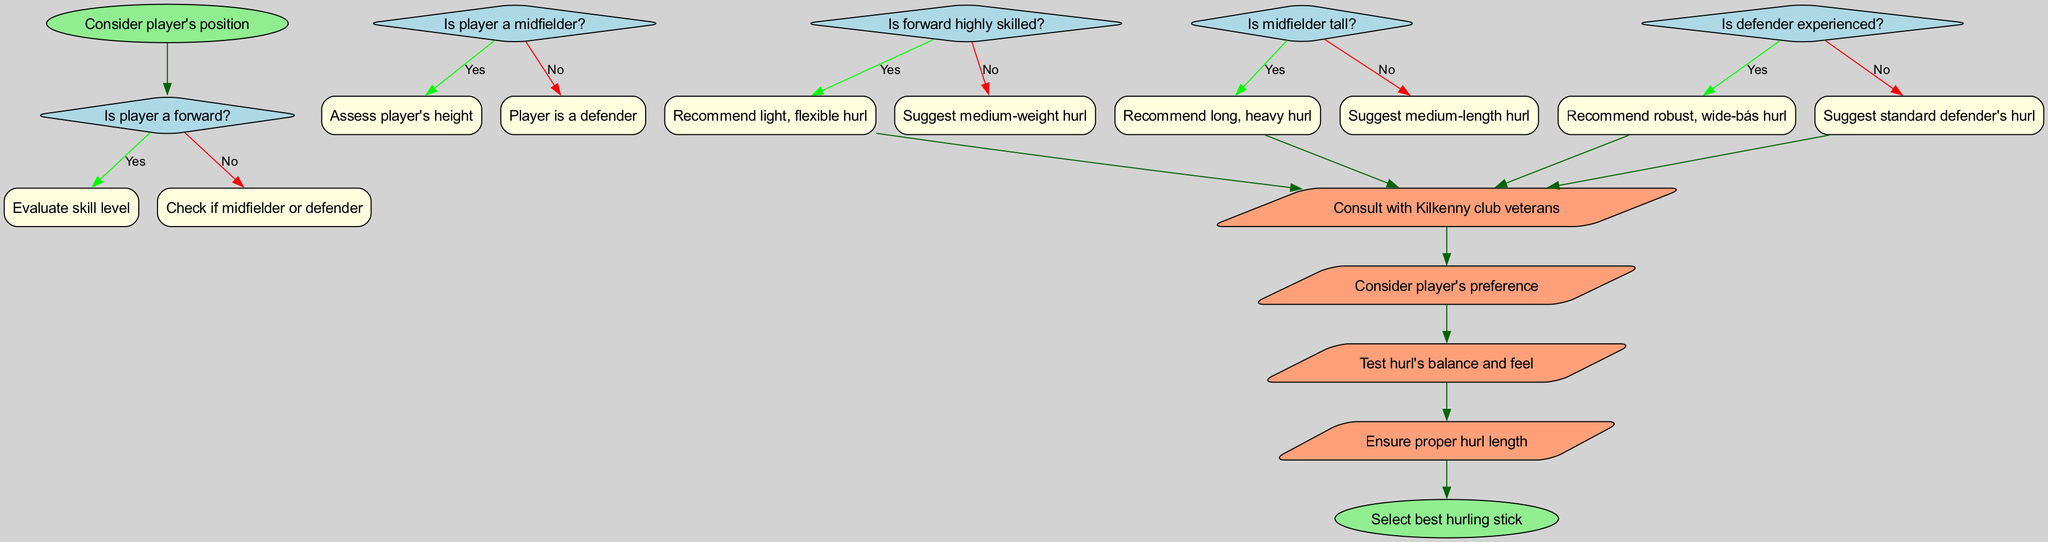What is the first step in the decision-making process? The first step is "Consider player's position", which is the starting node of the flowchart that initiates the decision-making process.
Answer: Consider player's position How many decision nodes are in the diagram? There are five decision nodes in the flowchart, with each node representing a different condition that affects the selection of the hurling stick.
Answer: Five What happens if a player is identified as a forward? If a player is identified as a forward, the next step is to "Evaluate skill level", which leads to further recommendations based on the player's skill.
Answer: Evaluate skill level If a player is a midfielder and tall, what is recommended? If a midfielder is tall, the recommendation is to "Recommend long, heavy hurl", which indicates the type of hurl suited to their height.
Answer: Recommend long, heavy hurl What is the final action before selecting the best hurling stick? The final action before reaching the end is to "Ensure proper hurl length", which is essential in confirming the hurling stick's suitability before selection.
Answer: Ensure proper hurl length What would a defender with limited experience be recommended? A defender with limited experience would be suggested to use a "standard defender's hurl", which implies a more basic option for less experienced players.
Answer: Suggest standard defender's hurl Which node follows the "Is forward highly skilled?" decision if the answer is yes? If the answer is yes to "Is forward highly skilled?", the next node would be "Recommend light, flexible hurl", indicating a specific selection based on skill.
Answer: Recommend light, flexible hurl What type of node connects with the "Player is a defender" decision? The "Player is a defender" decision connects to the subsequent decision regarding whether the defender is experienced, indicating the next question in the flow.
Answer: Check if defender is experienced 